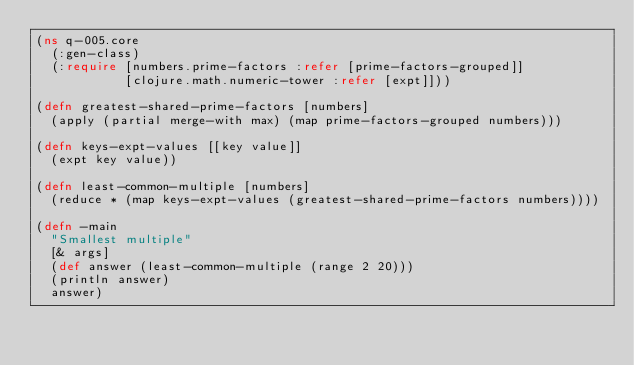Convert code to text. <code><loc_0><loc_0><loc_500><loc_500><_Clojure_>(ns q-005.core
  (:gen-class)
  (:require [numbers.prime-factors :refer [prime-factors-grouped]]
            [clojure.math.numeric-tower :refer [expt]]))

(defn greatest-shared-prime-factors [numbers]
  (apply (partial merge-with max) (map prime-factors-grouped numbers)))

(defn keys-expt-values [[key value]]
  (expt key value))

(defn least-common-multiple [numbers]
  (reduce * (map keys-expt-values (greatest-shared-prime-factors numbers))))

(defn -main
  "Smallest multiple"
  [& args]
  (def answer (least-common-multiple (range 2 20)))
  (println answer)
  answer)
</code> 